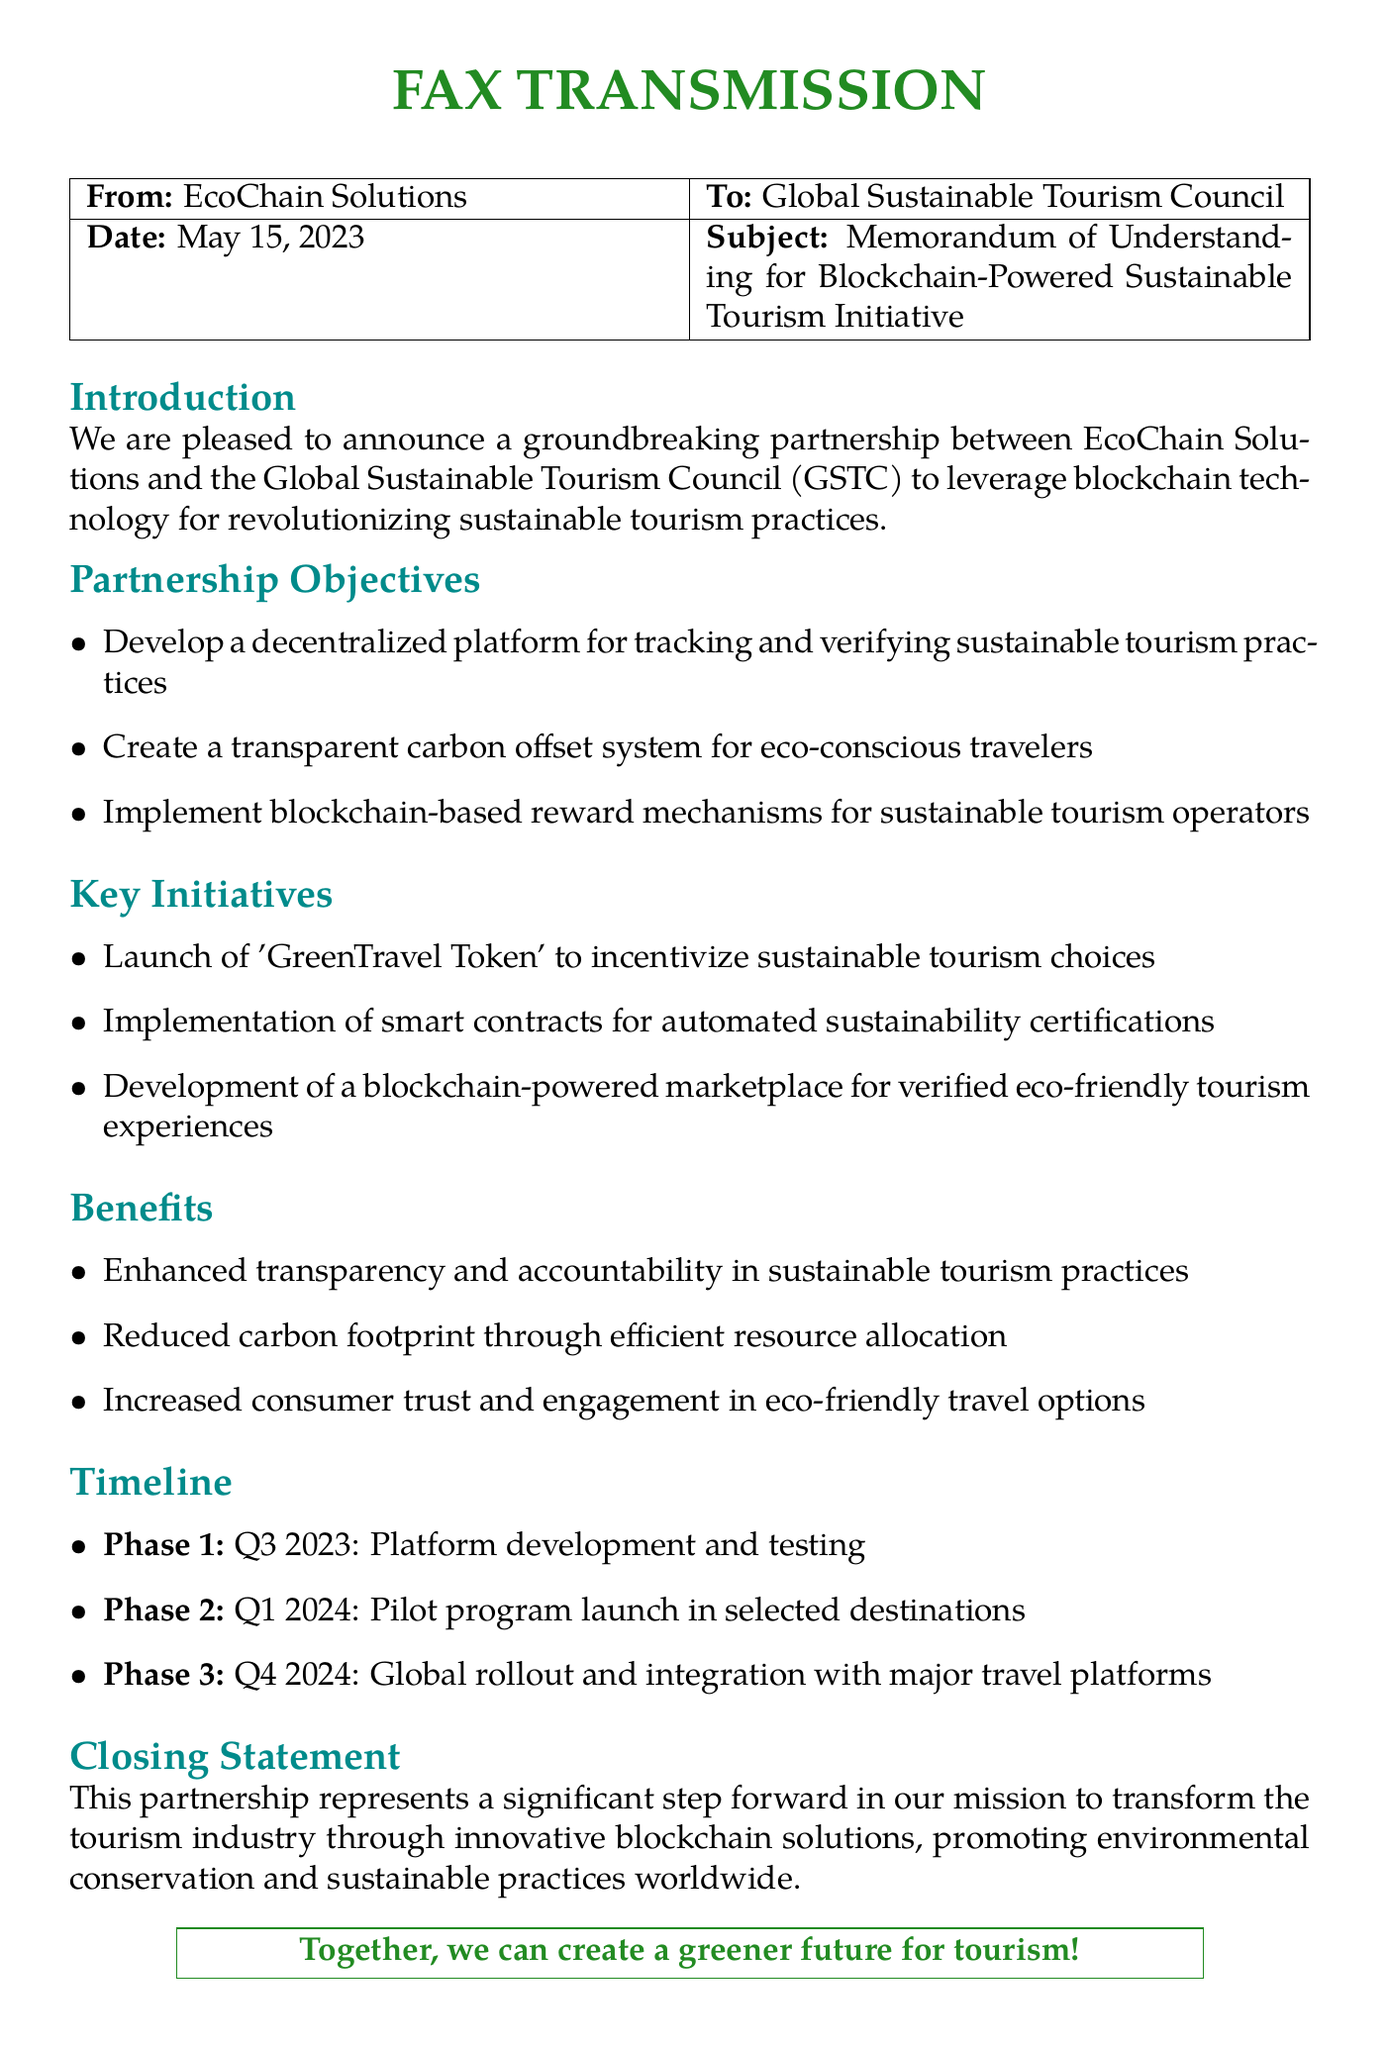What is the date of the fax? The date mentioned in the fax is May 15, 2023.
Answer: May 15, 2023 Who are the partners in the memorandum? The partners mentioned in the document are EcoChain Solutions and the Global Sustainable Tourism Council.
Answer: EcoChain Solutions and Global Sustainable Tourism Council What is one of the key initiatives listed? The document lists the launch of 'GreenTravel Token' as one of the key initiatives.
Answer: 'GreenTravel Token' What is the benefit related to transparency? The document states that enhanced transparency and accountability in sustainable tourism practices is one of the benefits.
Answer: Enhanced transparency and accountability In which quarter is the platform development scheduled? The document specifies the platform development and testing phase for Q3 2023.
Answer: Q3 2023 What type of document is this? The document is identified as a fax transmission.
Answer: Fax transmission What is the title of the subject in the fax? The subject title stated in the fax is 'Memorandum of Understanding for Blockchain-Powered Sustainable Tourism Initiative'.
Answer: Memorandum of Understanding for Blockchain-Powered Sustainable Tourism Initiative How many phases are outlined in the timeline? The timeline outlines three phases for the initiative.
Answer: Three phases 